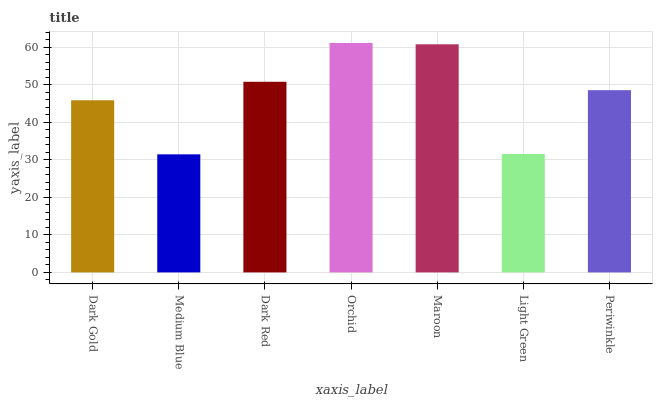Is Medium Blue the minimum?
Answer yes or no. Yes. Is Orchid the maximum?
Answer yes or no. Yes. Is Dark Red the minimum?
Answer yes or no. No. Is Dark Red the maximum?
Answer yes or no. No. Is Dark Red greater than Medium Blue?
Answer yes or no. Yes. Is Medium Blue less than Dark Red?
Answer yes or no. Yes. Is Medium Blue greater than Dark Red?
Answer yes or no. No. Is Dark Red less than Medium Blue?
Answer yes or no. No. Is Periwinkle the high median?
Answer yes or no. Yes. Is Periwinkle the low median?
Answer yes or no. Yes. Is Medium Blue the high median?
Answer yes or no. No. Is Medium Blue the low median?
Answer yes or no. No. 